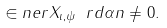Convert formula to latex. <formula><loc_0><loc_0><loc_500><loc_500>\in n e r { X _ { \iota , \psi } \ r d \alpha } { n } \neq 0 .</formula> 